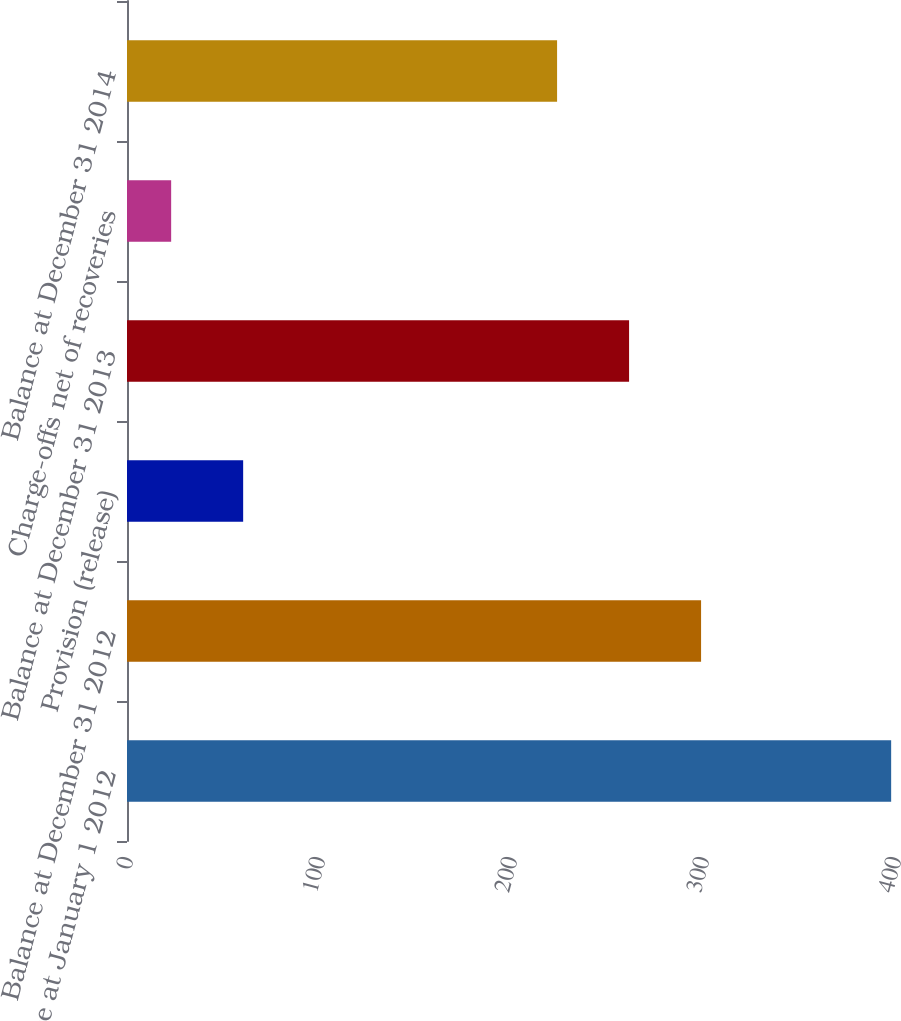<chart> <loc_0><loc_0><loc_500><loc_500><bar_chart><fcel>Balance at January 1 2012<fcel>Balance at December 31 2012<fcel>Provision (release)<fcel>Balance at December 31 2013<fcel>Charge-offs net of recoveries<fcel>Balance at December 31 2014<nl><fcel>398<fcel>299<fcel>60.5<fcel>261.5<fcel>23<fcel>224<nl></chart> 